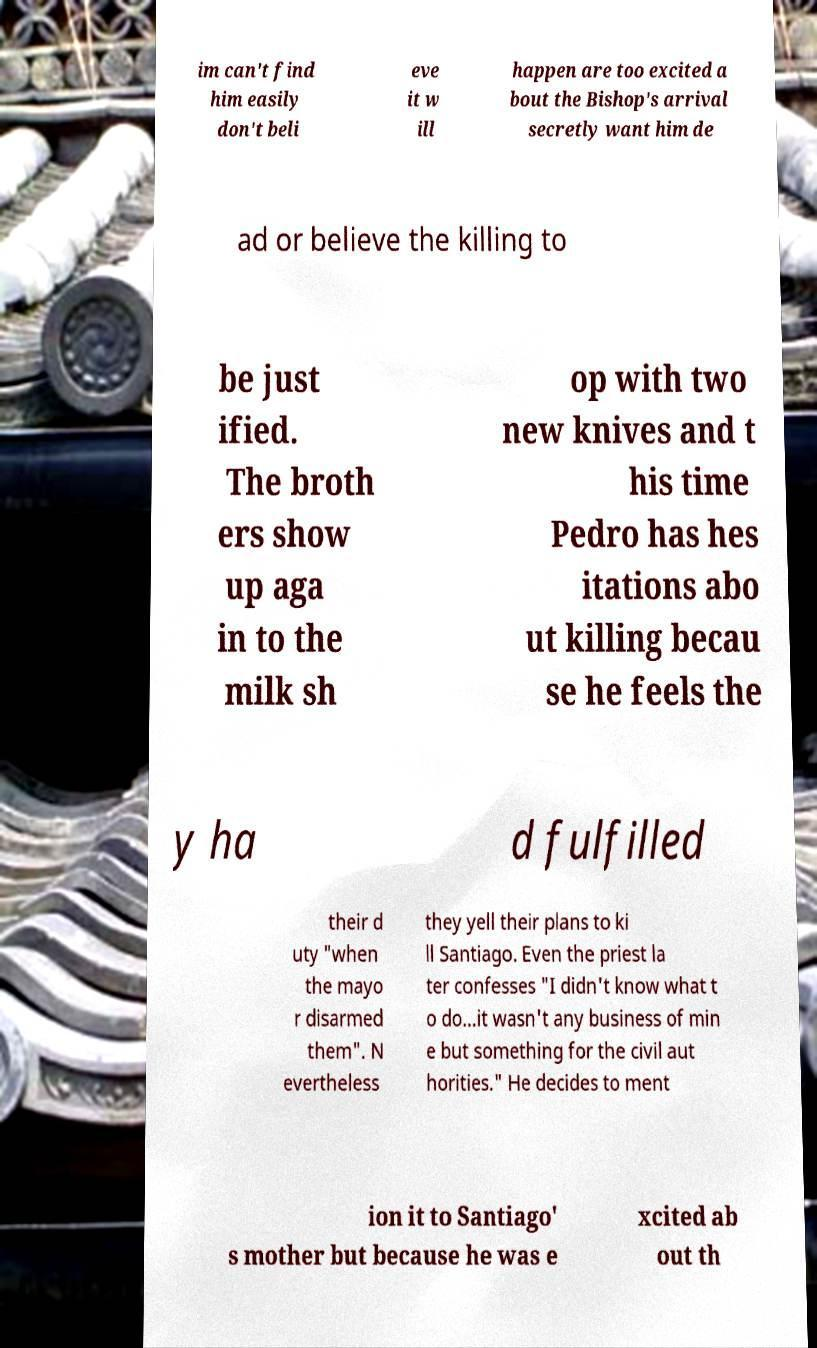Please identify and transcribe the text found in this image. im can't find him easily don't beli eve it w ill happen are too excited a bout the Bishop's arrival secretly want him de ad or believe the killing to be just ified. The broth ers show up aga in to the milk sh op with two new knives and t his time Pedro has hes itations abo ut killing becau se he feels the y ha d fulfilled their d uty "when the mayo r disarmed them". N evertheless they yell their plans to ki ll Santiago. Even the priest la ter confesses "I didn't know what t o do...it wasn't any business of min e but something for the civil aut horities." He decides to ment ion it to Santiago' s mother but because he was e xcited ab out th 